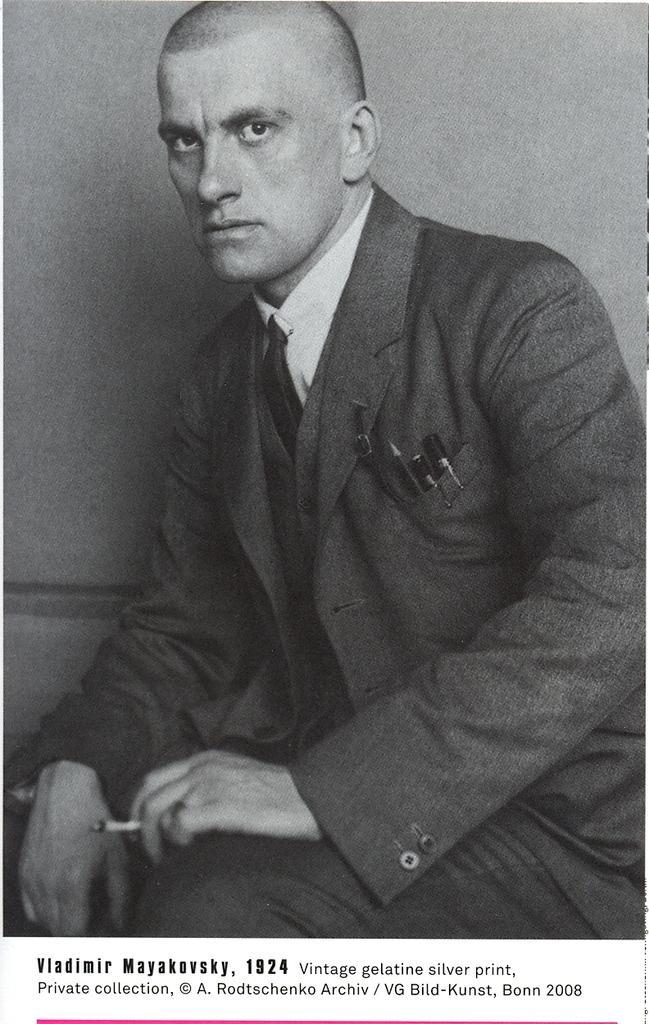Describe this image in one or two sentences. This is a black and white image. In the background there is wall. 